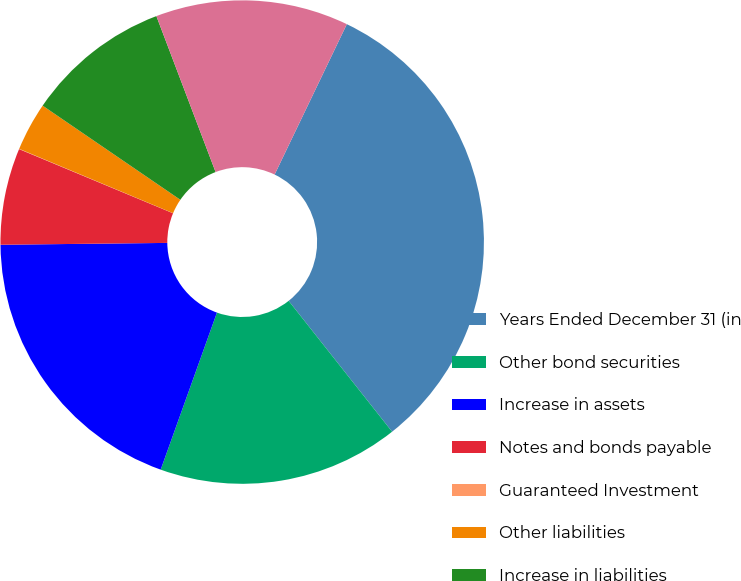Convert chart. <chart><loc_0><loc_0><loc_500><loc_500><pie_chart><fcel>Years Ended December 31 (in<fcel>Other bond securities<fcel>Increase in assets<fcel>Notes and bonds payable<fcel>Guaranteed Investment<fcel>Other liabilities<fcel>Increase in liabilities<fcel>Net increase to pre-tax<nl><fcel>32.23%<fcel>16.12%<fcel>19.35%<fcel>6.46%<fcel>0.02%<fcel>3.24%<fcel>9.68%<fcel>12.9%<nl></chart> 